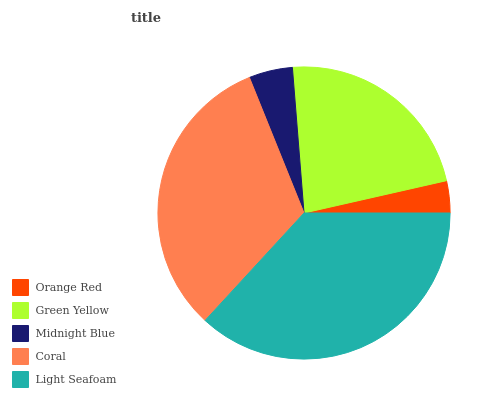Is Orange Red the minimum?
Answer yes or no. Yes. Is Light Seafoam the maximum?
Answer yes or no. Yes. Is Green Yellow the minimum?
Answer yes or no. No. Is Green Yellow the maximum?
Answer yes or no. No. Is Green Yellow greater than Orange Red?
Answer yes or no. Yes. Is Orange Red less than Green Yellow?
Answer yes or no. Yes. Is Orange Red greater than Green Yellow?
Answer yes or no. No. Is Green Yellow less than Orange Red?
Answer yes or no. No. Is Green Yellow the high median?
Answer yes or no. Yes. Is Green Yellow the low median?
Answer yes or no. Yes. Is Orange Red the high median?
Answer yes or no. No. Is Orange Red the low median?
Answer yes or no. No. 